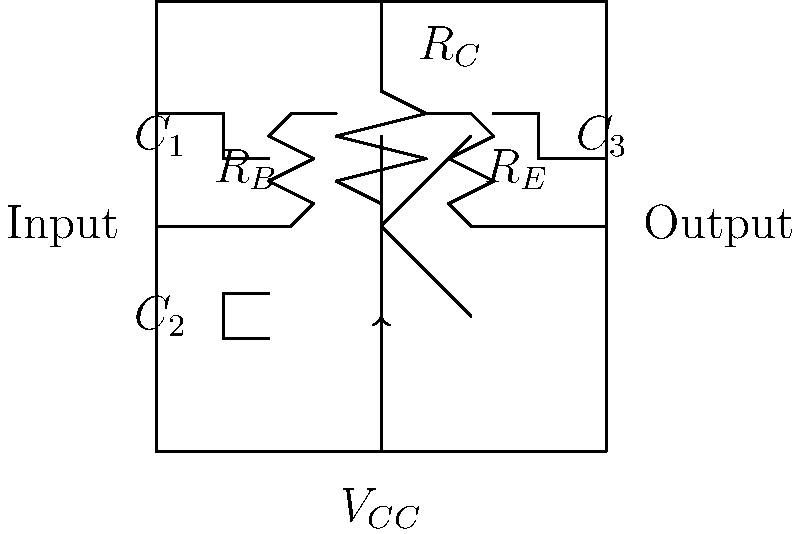In this basic transistor amplifier circuit, which component is responsible for providing the DC bias to the transistor's base, and how does it contribute to the overall function of the amplifier? To answer this question, let's break down the components and their functions in this circuit:

1. The transistor is the central component, amplifying the input signal.

2. $R_C$ (collector resistor) is the load resistor, converting current changes to voltage changes at the output.

3. $R_E$ (emitter resistor) provides negative feedback, stabilizing the circuit's operating point.

4. $C_1$, $C_2$, and $C_3$ are coupling capacitors, allowing AC signals to pass while blocking DC.

5. $R_B$ (base resistor) is the key component for this question. It provides the DC bias to the transistor's base, which is crucial for the amplifier's operation.

The function of $R_B$ in this circuit is to:

a) Establish the DC operating point of the transistor by providing a small current to the base.
b) Set the transistor in its active region, allowing it to amplify signals.
c) Work in conjunction with $R_E$ to stabilize the circuit against temperature variations and transistor parameter spread.

By providing the appropriate DC bias, $R_B$ ensures that the transistor can faithfully amplify the AC input signal without distortion. This bias allows the transistor to operate in its linear region, where small changes in base current result in proportional changes in collector current, thus achieving amplification.
Answer: $R_B$ (base resistor) provides DC bias, setting the transistor's operating point for proper amplification. 